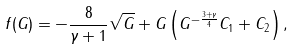Convert formula to latex. <formula><loc_0><loc_0><loc_500><loc_500>f ( G ) = - \frac { 8 } { \gamma + 1 } \sqrt { G } + G \left ( G ^ { - \frac { 3 + \gamma } { 4 } } C _ { 1 } + C _ { 2 } \right ) ,</formula> 